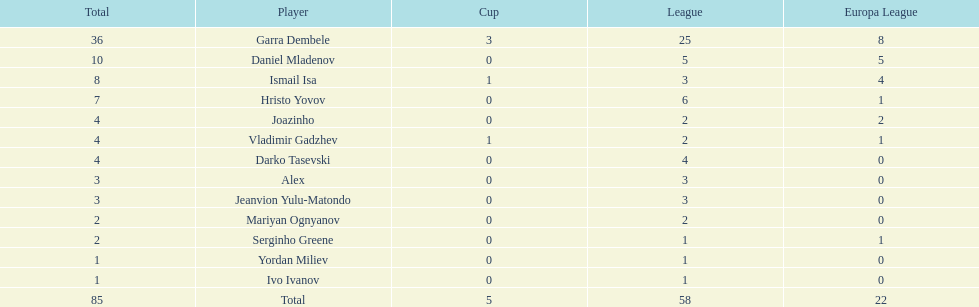Who had the most goal scores? Garra Dembele. Give me the full table as a dictionary. {'header': ['Total', 'Player', 'Cup', 'League', 'Europa League'], 'rows': [['36', 'Garra Dembele', '3', '25', '8'], ['10', 'Daniel Mladenov', '0', '5', '5'], ['8', 'Ismail Isa', '1', '3', '4'], ['7', 'Hristo Yovov', '0', '6', '1'], ['4', 'Joazinho', '0', '2', '2'], ['4', 'Vladimir Gadzhev', '1', '2', '1'], ['4', 'Darko Tasevski', '0', '4', '0'], ['3', 'Alex', '0', '3', '0'], ['3', 'Jeanvion Yulu-Matondo', '0', '3', '0'], ['2', 'Mariyan Ognyanov', '0', '2', '0'], ['2', 'Serginho Greene', '0', '1', '1'], ['1', 'Yordan Miliev', '0', '1', '0'], ['1', 'Ivo Ivanov', '0', '1', '0'], ['85', 'Total', '5', '58', '22']]} 